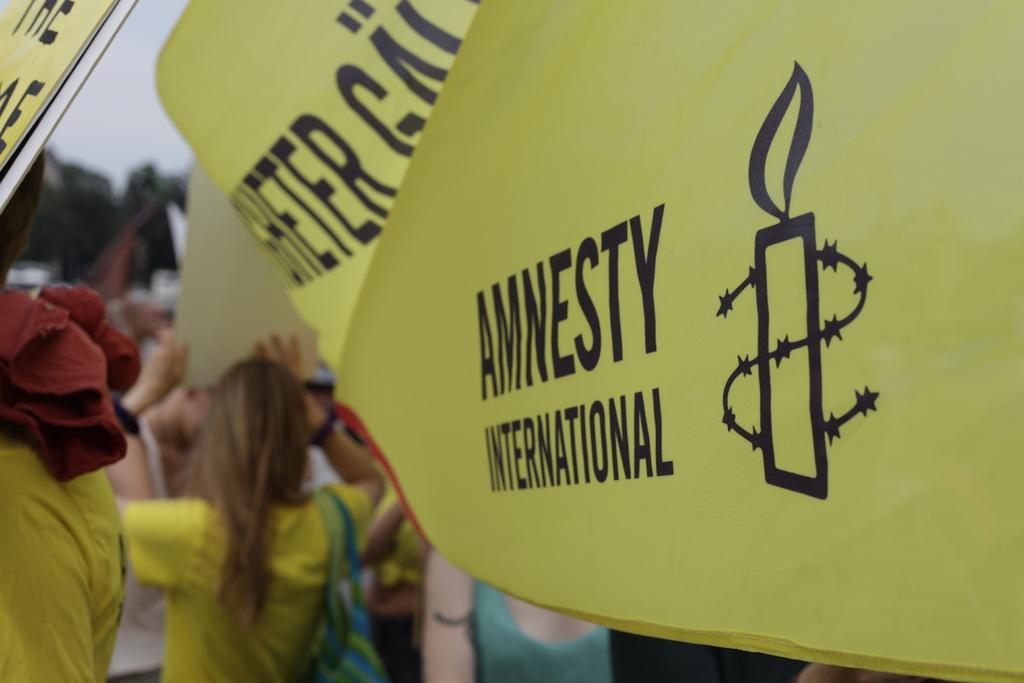How would you summarize this image in a sentence or two? In this picture we can see placards and people. In the background there is greenery and sky. 